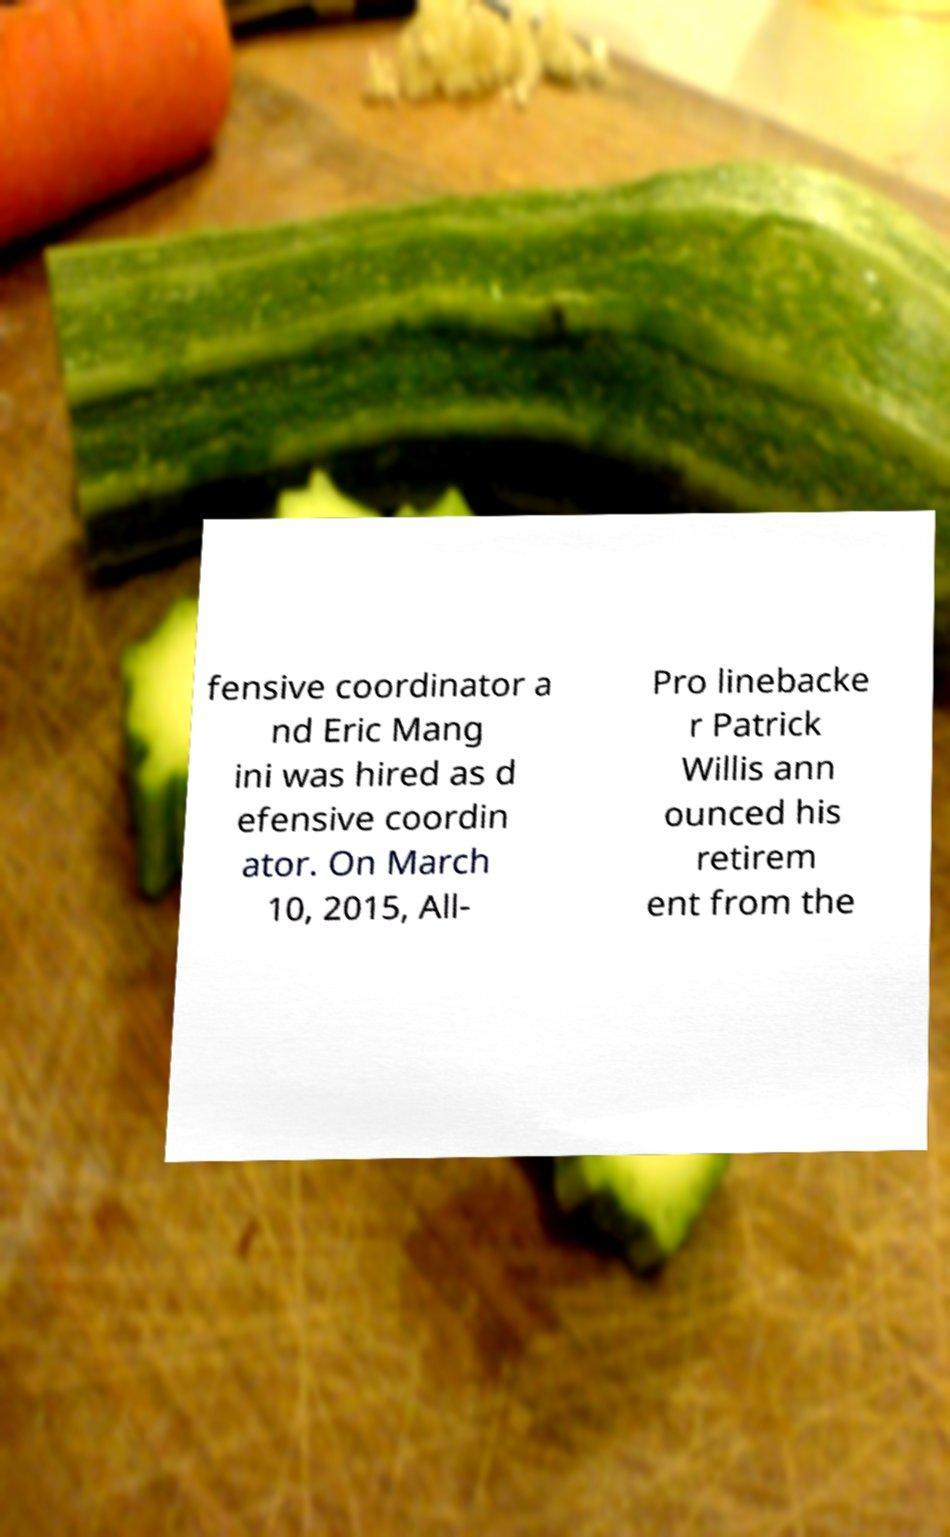Can you read and provide the text displayed in the image?This photo seems to have some interesting text. Can you extract and type it out for me? fensive coordinator a nd Eric Mang ini was hired as d efensive coordin ator. On March 10, 2015, All- Pro linebacke r Patrick Willis ann ounced his retirem ent from the 